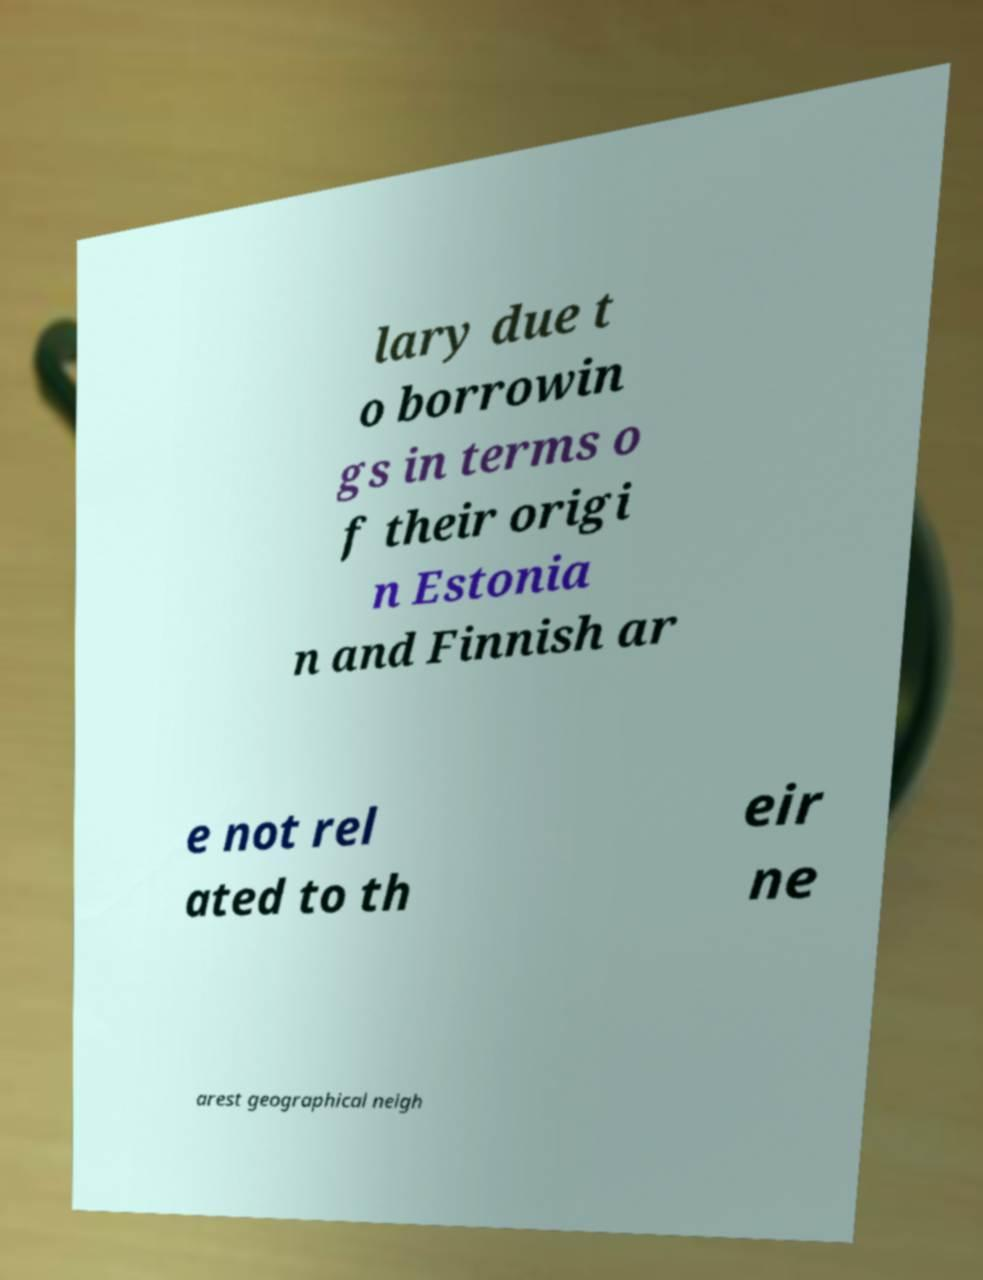Please read and relay the text visible in this image. What does it say? lary due t o borrowin gs in terms o f their origi n Estonia n and Finnish ar e not rel ated to th eir ne arest geographical neigh 